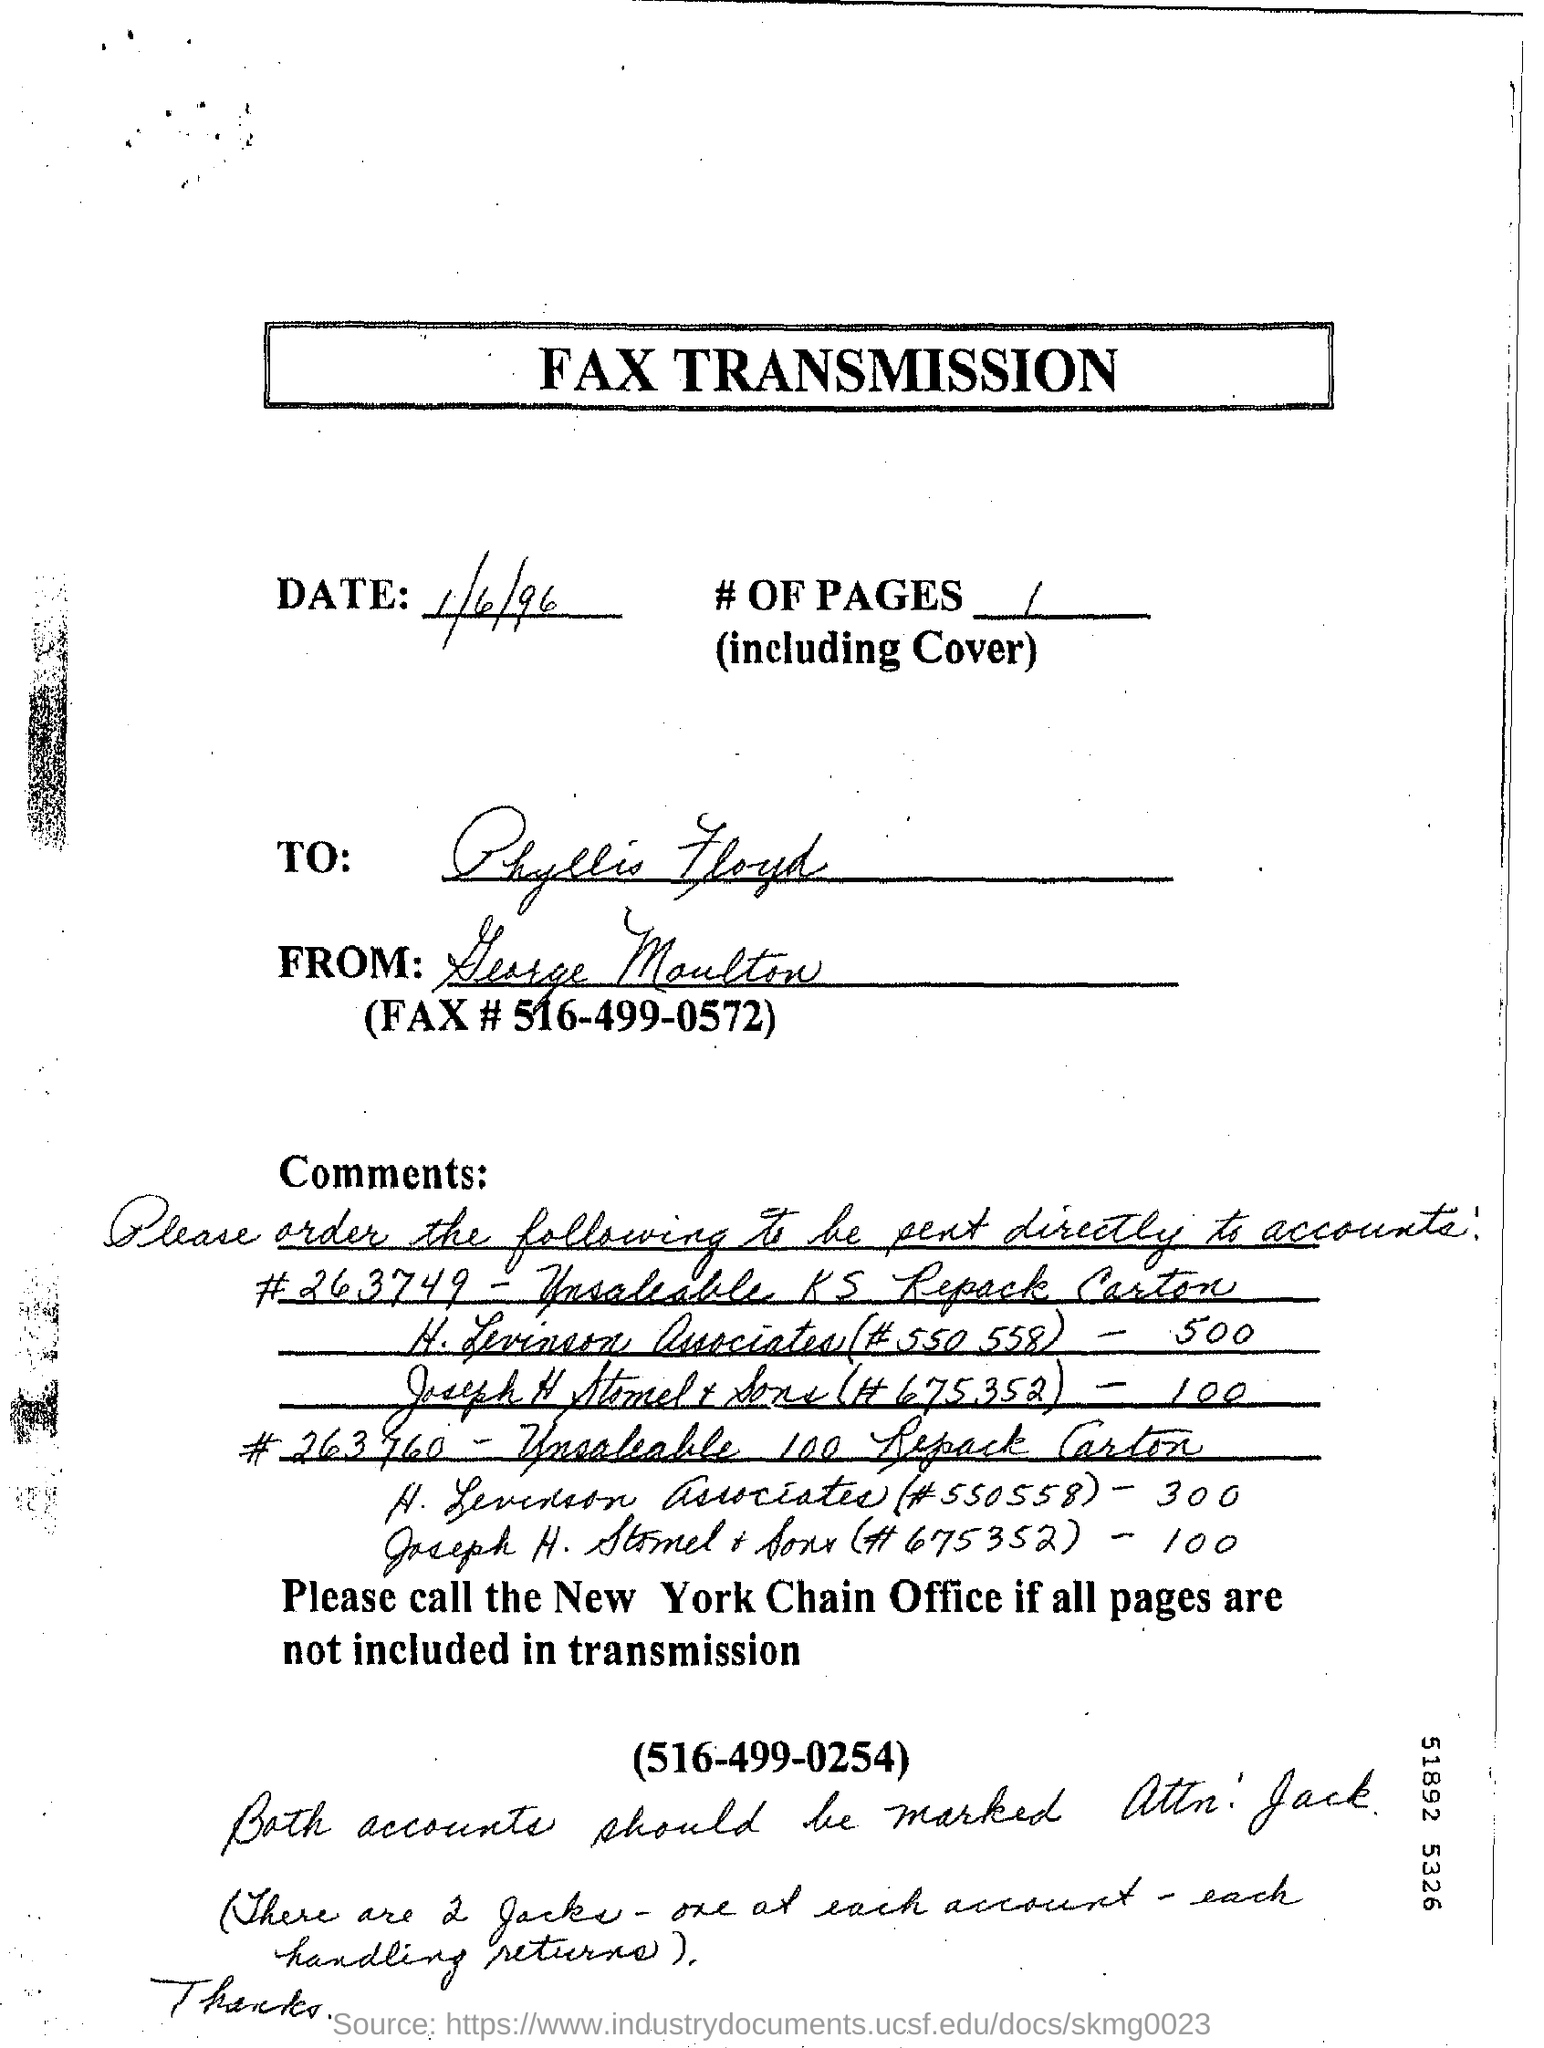What is the name of this document ?
Ensure brevity in your answer.  Fax transmission. 